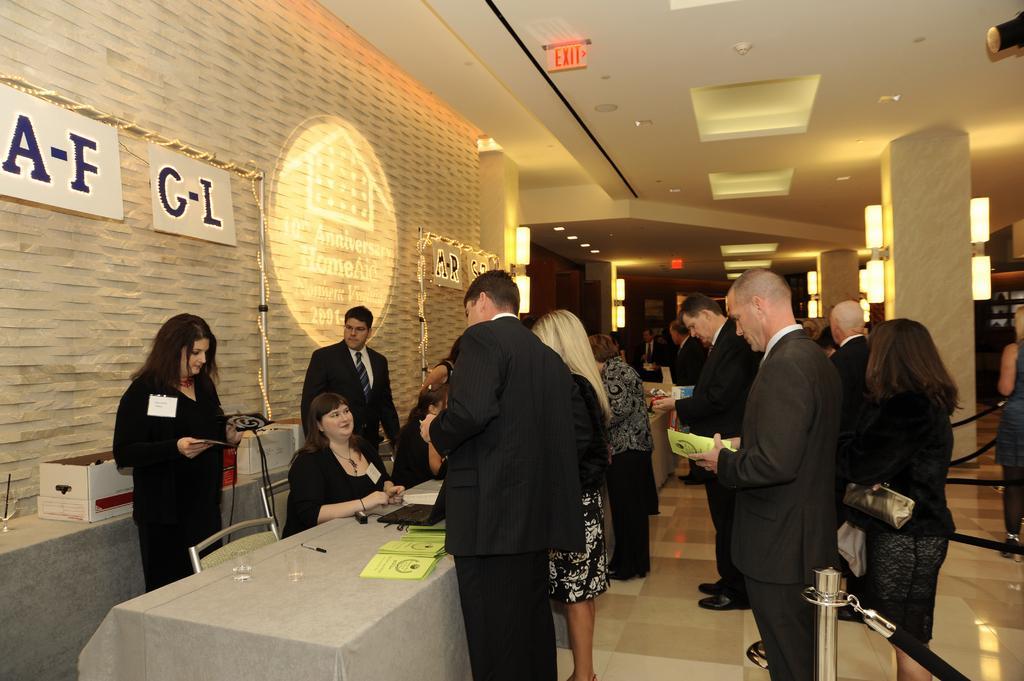Could you give a brief overview of what you see in this image? As we can see in the image there is a wall, lights, tables, chairs, boxes and few people standing here and there. On table there is a laptop and books. 